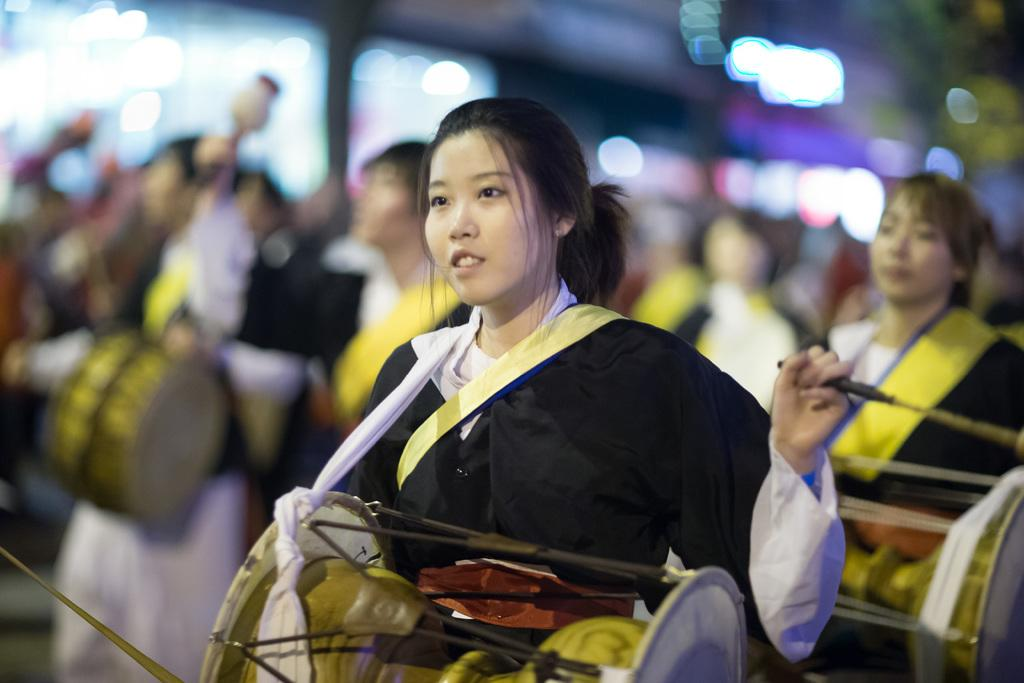What is the woman in the image doing? The woman is playing a drum using a pair of sticks. What can be observed about the woman's attire? The woman is wearing a black color coat. Are there any other musicians in the image? Yes, there are other women playing drums in the background. What type of brass instrument is the woman playing in the image? The woman is not playing a brass instrument; she is playing a drum. How does the woman's wealth affect her ability to play the drum in the image? The image does not provide any information about the woman's wealth, and therefore it cannot be determined how it might affect her ability to play the drum. 